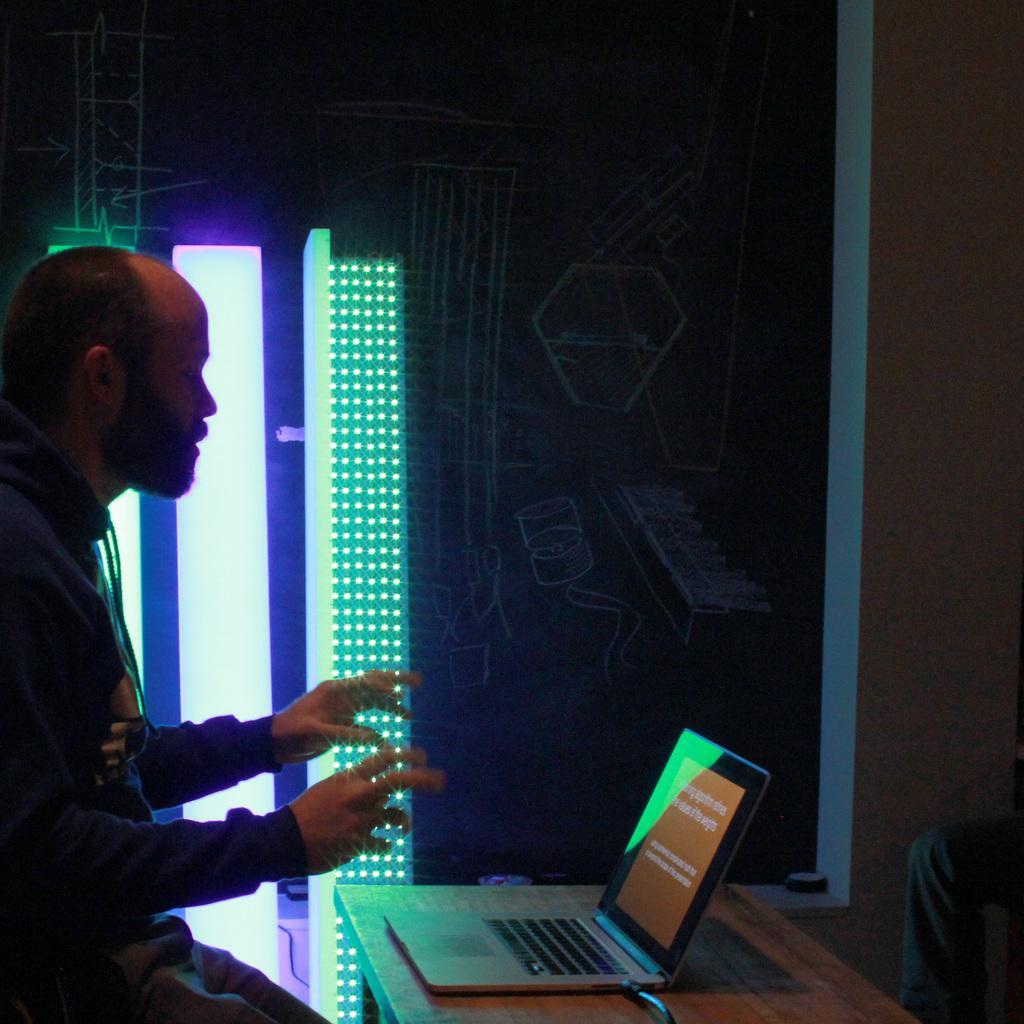Could you give a brief overview of what you see in this image? In this image we can see a man sitting on the seating stool and a table is placed in front of him. On the table there is a laptop. In the background there are walls and a person standing on the chair. 